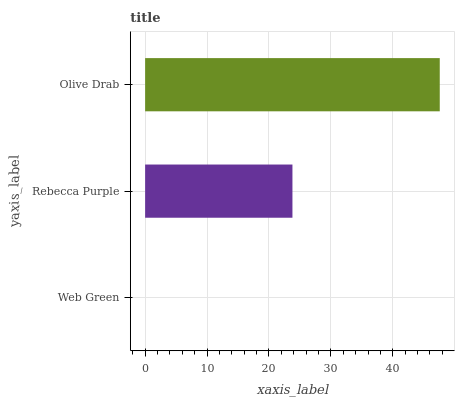Is Web Green the minimum?
Answer yes or no. Yes. Is Olive Drab the maximum?
Answer yes or no. Yes. Is Rebecca Purple the minimum?
Answer yes or no. No. Is Rebecca Purple the maximum?
Answer yes or no. No. Is Rebecca Purple greater than Web Green?
Answer yes or no. Yes. Is Web Green less than Rebecca Purple?
Answer yes or no. Yes. Is Web Green greater than Rebecca Purple?
Answer yes or no. No. Is Rebecca Purple less than Web Green?
Answer yes or no. No. Is Rebecca Purple the high median?
Answer yes or no. Yes. Is Rebecca Purple the low median?
Answer yes or no. Yes. Is Olive Drab the high median?
Answer yes or no. No. Is Web Green the low median?
Answer yes or no. No. 